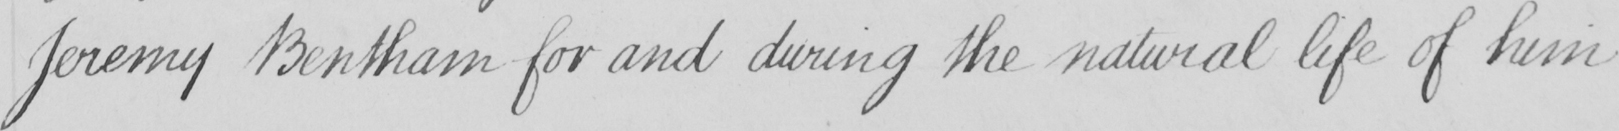Can you read and transcribe this handwriting? Jeremy Bentham for and during the natural life of him 